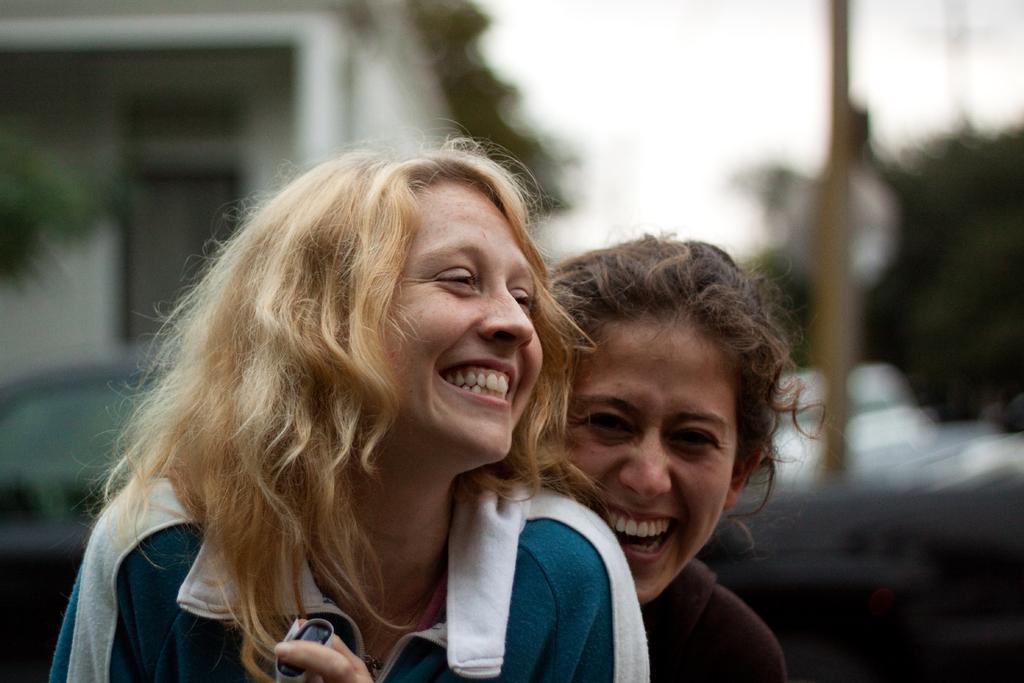How would you summarize this image in a sentence or two? In this picture we can see two women are smiling in the front, on the left side there is a building, it looks like a tree in the background, there is a blurry background. 